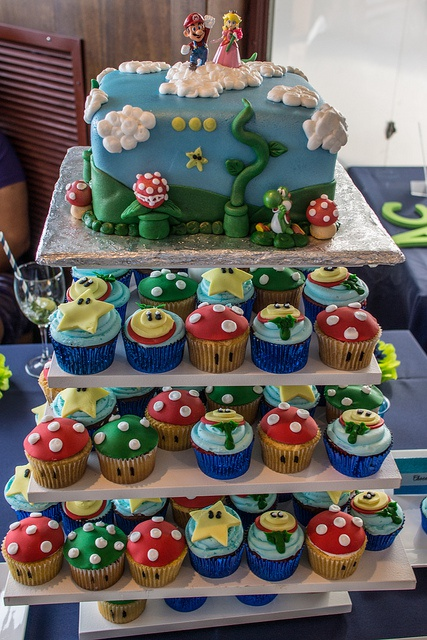Describe the objects in this image and their specific colors. I can see cake in gray, black, blue, and darkgreen tones, cake in gray, maroon, and brown tones, cake in gray, darkgreen, and maroon tones, cake in gray, navy, black, teal, and darkgray tones, and cake in gray, navy, black, tan, and maroon tones in this image. 